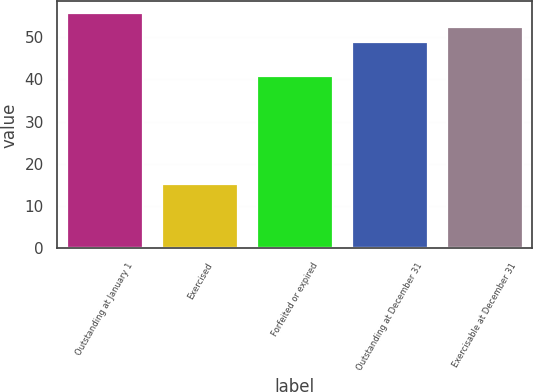<chart> <loc_0><loc_0><loc_500><loc_500><bar_chart><fcel>Outstanding at January 1<fcel>Exercised<fcel>Forfeited or expired<fcel>Outstanding at December 31<fcel>Exercisable at December 31<nl><fcel>55.72<fcel>15.32<fcel>40.73<fcel>48.97<fcel>52.34<nl></chart> 